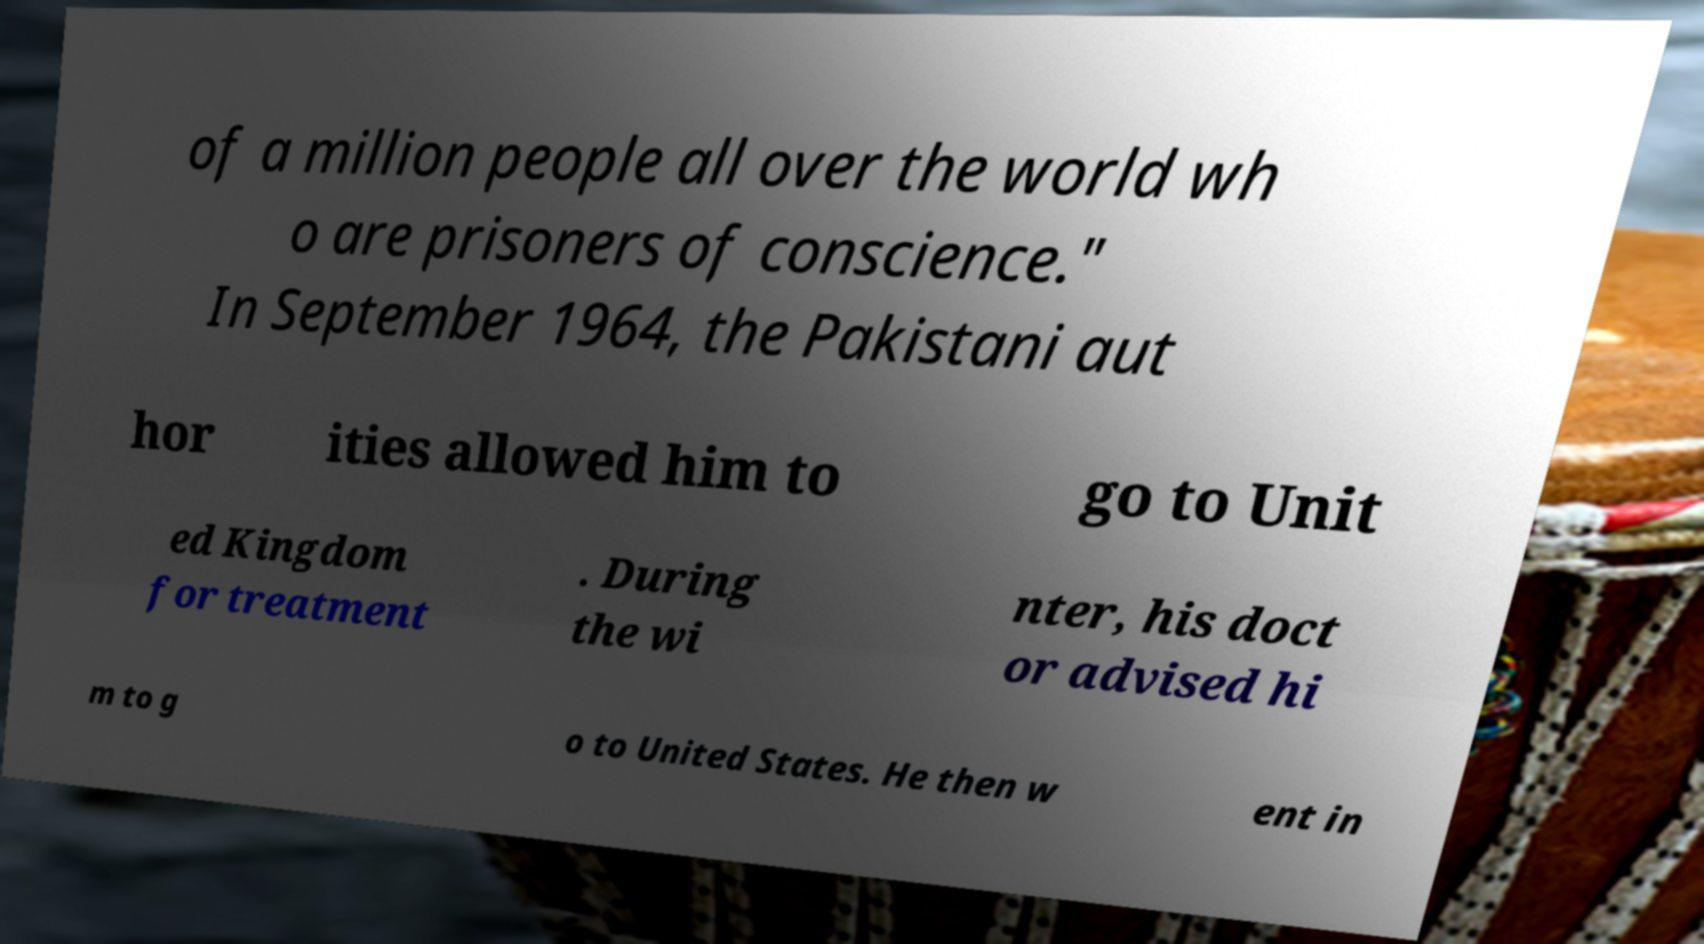Can you read and provide the text displayed in the image?This photo seems to have some interesting text. Can you extract and type it out for me? of a million people all over the world wh o are prisoners of conscience." In September 1964, the Pakistani aut hor ities allowed him to go to Unit ed Kingdom for treatment . During the wi nter, his doct or advised hi m to g o to United States. He then w ent in 